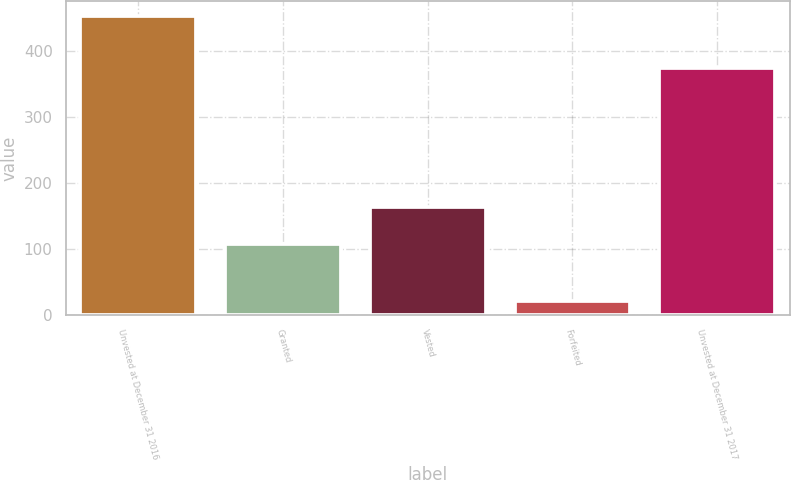<chart> <loc_0><loc_0><loc_500><loc_500><bar_chart><fcel>Unvested at December 31 2016<fcel>Granted<fcel>Vested<fcel>Forfeited<fcel>Unvested at December 31 2017<nl><fcel>453<fcel>107<fcel>164<fcel>22<fcel>374<nl></chart> 